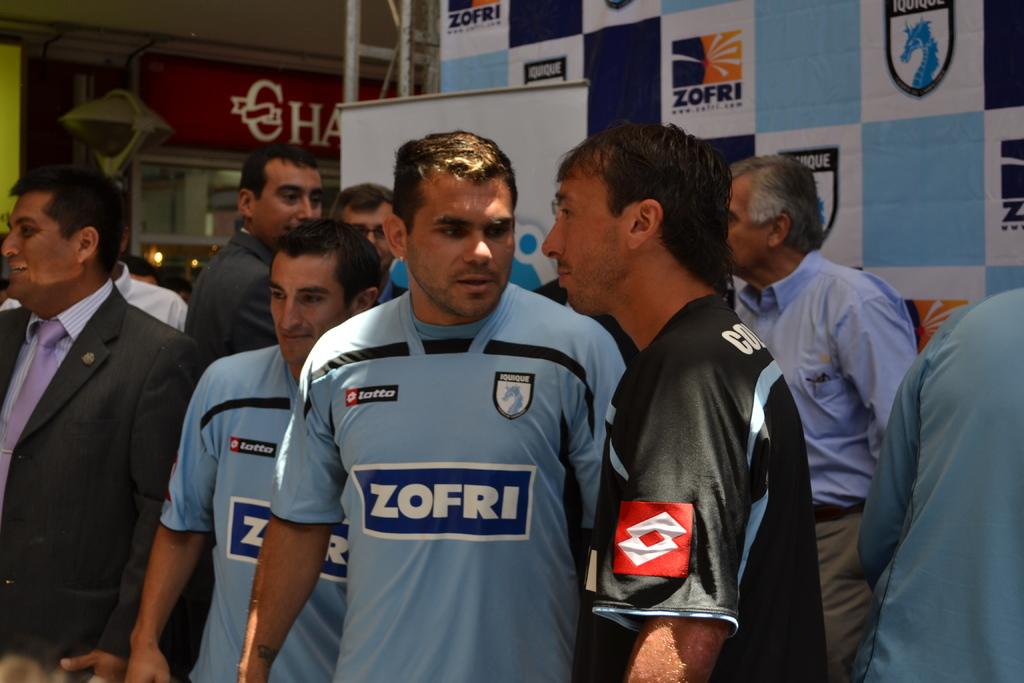Who is sponsoring the shirt?
Your answer should be very brief. Zofri. 